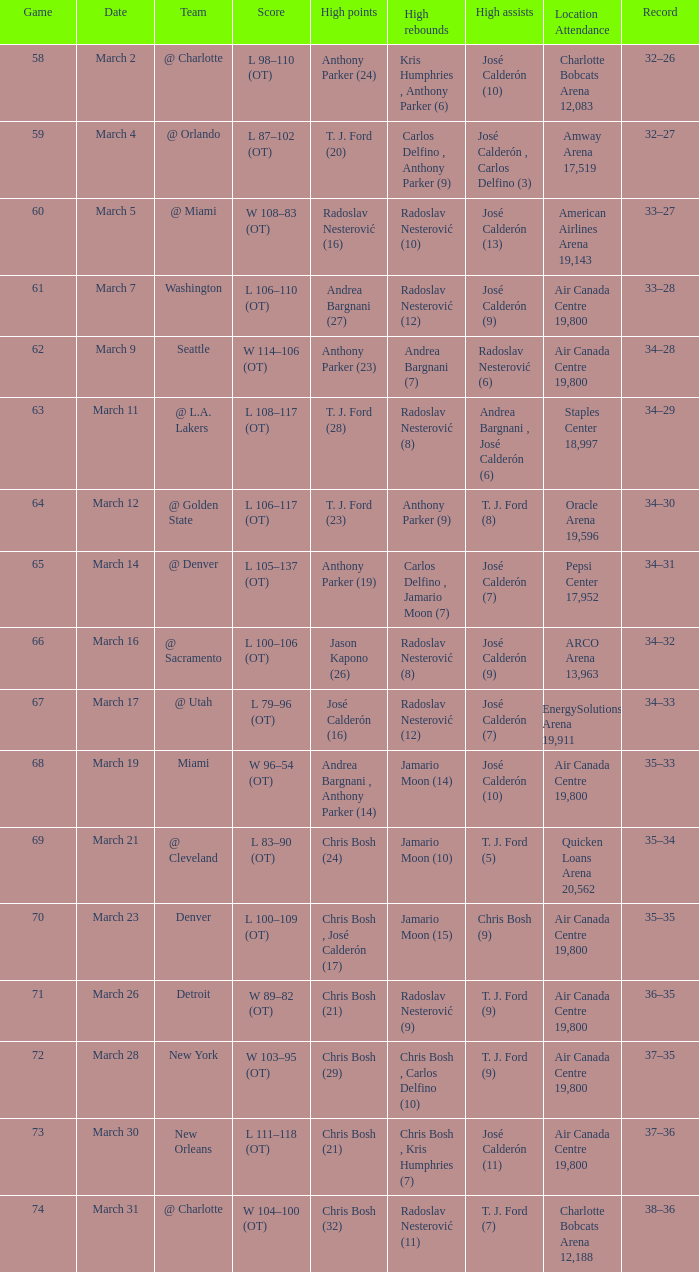How many attended the game on march 16 after over 64 games? ARCO Arena 13,963. 